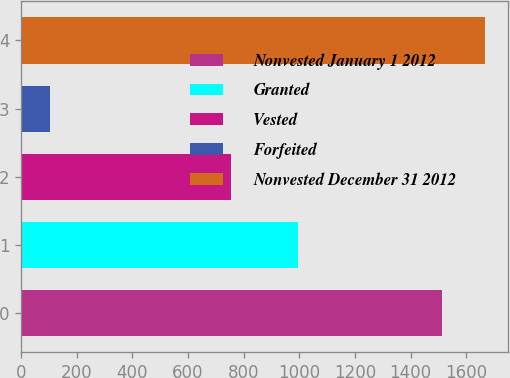Convert chart. <chart><loc_0><loc_0><loc_500><loc_500><bar_chart><fcel>Nonvested January 1 2012<fcel>Granted<fcel>Vested<fcel>Forfeited<fcel>Nonvested December 31 2012<nl><fcel>1513<fcel>996<fcel>756<fcel>105<fcel>1667.3<nl></chart> 